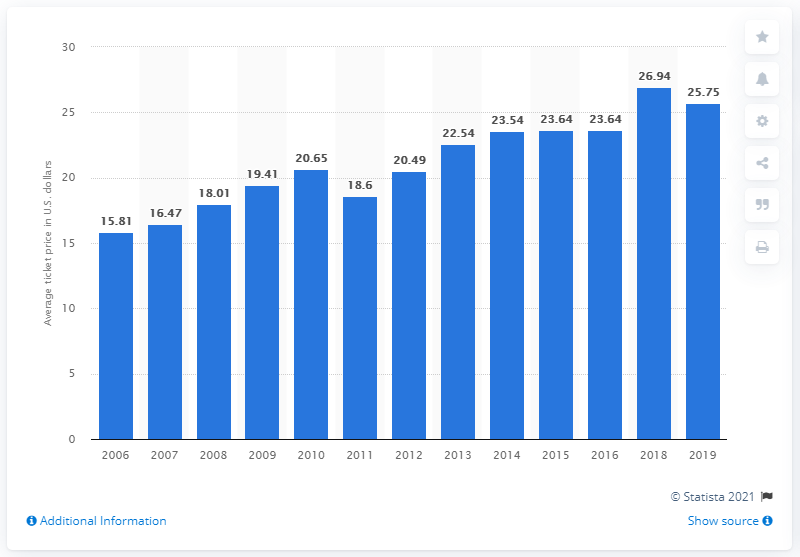Identify some key points in this picture. The average ticket price for Texas Rangers games in 2019 was $25.75. 